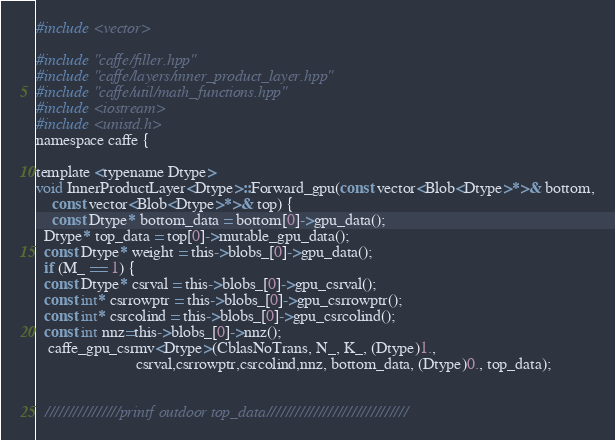<code> <loc_0><loc_0><loc_500><loc_500><_Cuda_>#include <vector>

#include "caffe/filler.hpp"
#include "caffe/layers/inner_product_layer.hpp"
#include "caffe/util/math_functions.hpp"
#include <iostream>
#include <unistd.h>
namespace caffe {

template <typename Dtype>
void InnerProductLayer<Dtype>::Forward_gpu(const vector<Blob<Dtype>*>& bottom,
    const vector<Blob<Dtype>*>& top) {
    const Dtype* bottom_data = bottom[0]->gpu_data();
  Dtype* top_data = top[0]->mutable_gpu_data();
  const Dtype* weight = this->blobs_[0]->gpu_data();
  if (M_ == 1) {
  const Dtype* csrval = this->blobs_[0]->gpu_csrval();
  const int* csrrowptr = this->blobs_[0]->gpu_csrrowptr();
  const int* csrcolind = this->blobs_[0]->gpu_csrcolind();
  const int nnz=this->blobs_[0]->nnz();
   caffe_gpu_csrmv<Dtype>(CblasNoTrans, N_, K_, (Dtype)1.,
                         csrval,csrrowptr,csrcolind,nnz, bottom_data, (Dtype)0., top_data);


  ////////////////printf outdoor top_data//////////////////////////////</code> 